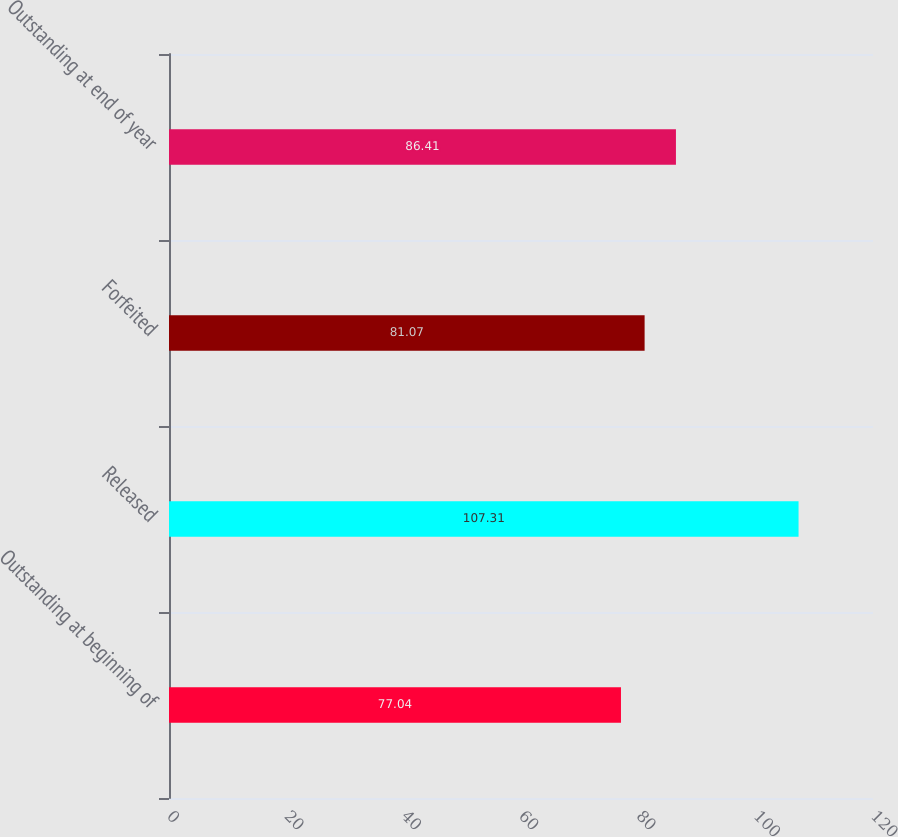<chart> <loc_0><loc_0><loc_500><loc_500><bar_chart><fcel>Outstanding at beginning of<fcel>Released<fcel>Forfeited<fcel>Outstanding at end of year<nl><fcel>77.04<fcel>107.31<fcel>81.07<fcel>86.41<nl></chart> 